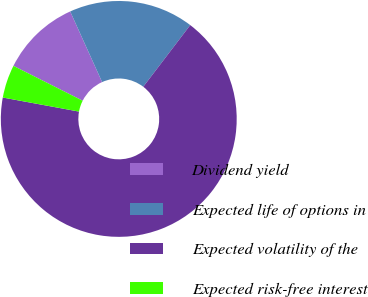Convert chart to OTSL. <chart><loc_0><loc_0><loc_500><loc_500><pie_chart><fcel>Dividend yield<fcel>Expected life of options in<fcel>Expected volatility of the<fcel>Expected risk-free interest<nl><fcel>10.82%<fcel>17.12%<fcel>67.54%<fcel>4.52%<nl></chart> 